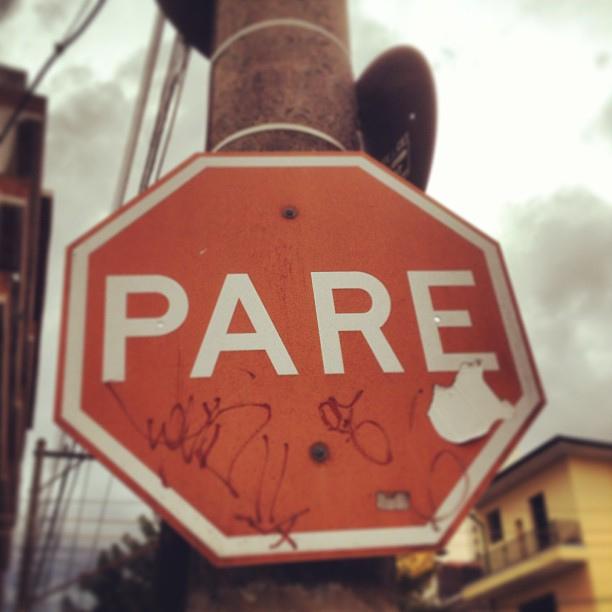What is on the sign?
Concise answer only. Pare. What color is the sign?
Short answer required. Red. What does the sign mean?
Write a very short answer. Stop. 